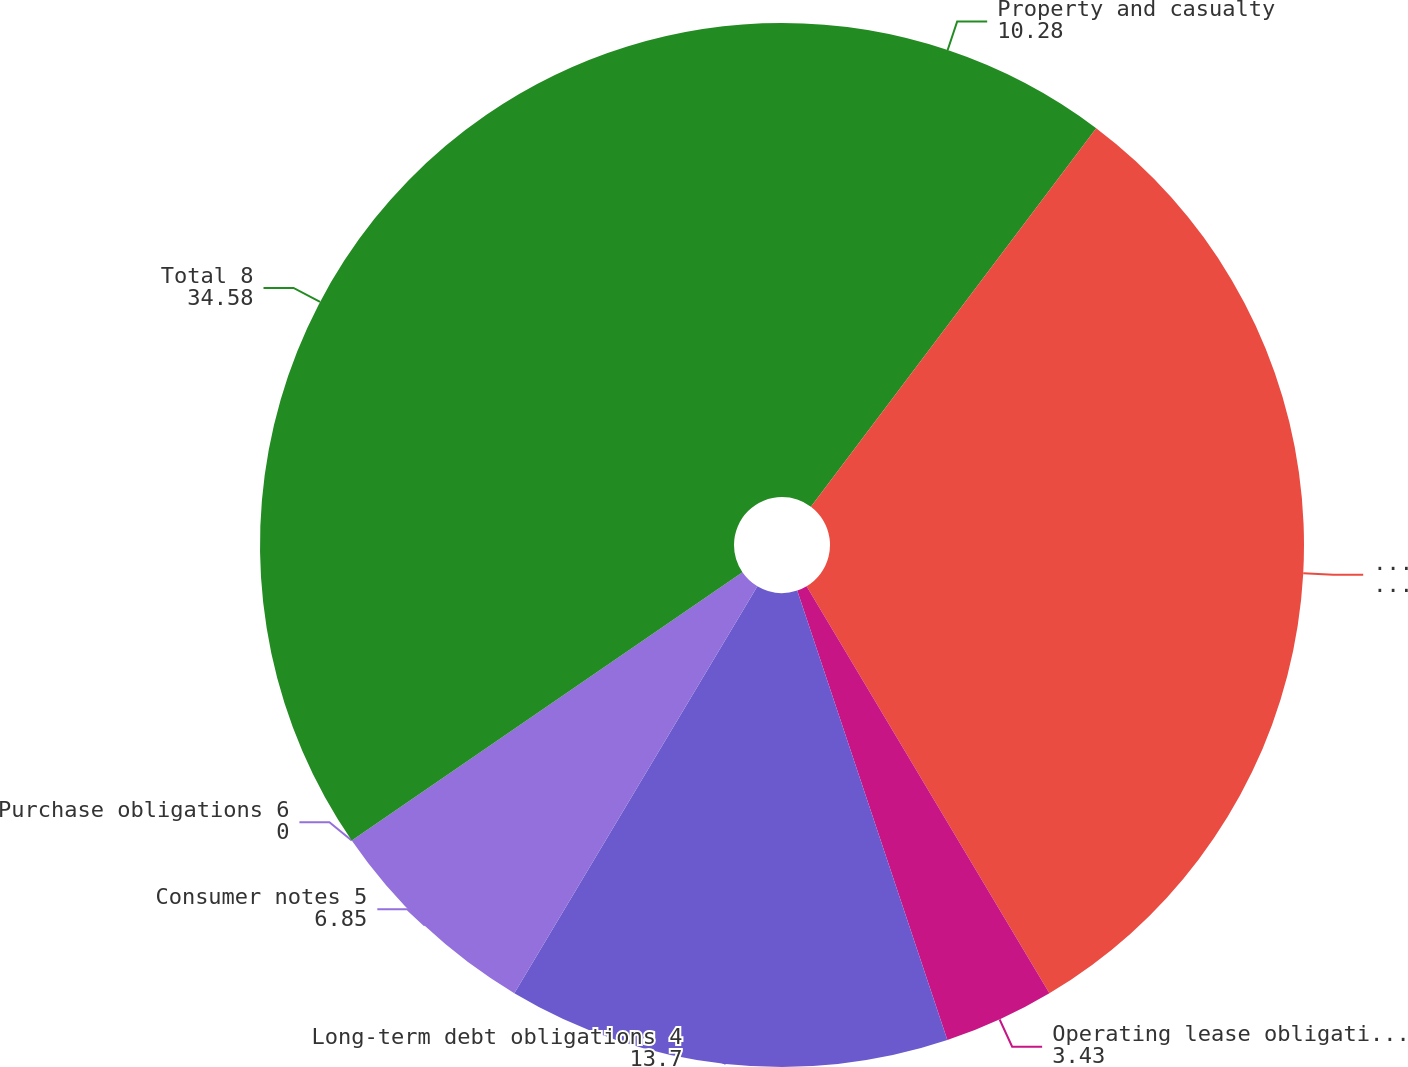Convert chart. <chart><loc_0><loc_0><loc_500><loc_500><pie_chart><fcel>Property and casualty<fcel>Life annuity and disability<fcel>Operating lease obligations 3<fcel>Long-term debt obligations 4<fcel>Consumer notes 5<fcel>Purchase obligations 6<fcel>Total 8<nl><fcel>10.28%<fcel>31.16%<fcel>3.43%<fcel>13.7%<fcel>6.85%<fcel>0.0%<fcel>34.58%<nl></chart> 